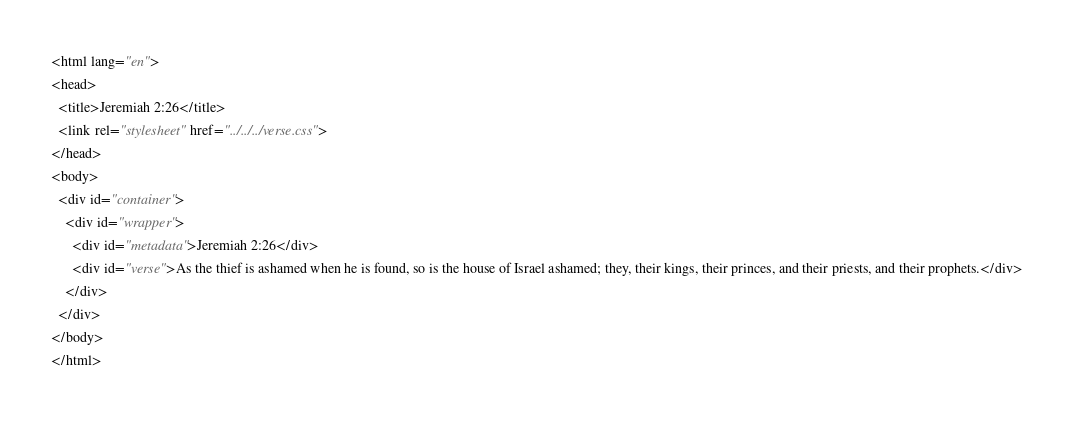Convert code to text. <code><loc_0><loc_0><loc_500><loc_500><_HTML_><html lang="en">
<head>
  <title>Jeremiah 2:26</title>
  <link rel="stylesheet" href="../../../verse.css">
</head>
<body>
  <div id="container">
    <div id="wrapper">
      <div id="metadata">Jeremiah 2:26</div>
      <div id="verse">As the thief is ashamed when he is found, so is the house of Israel ashamed; they, their kings, their princes, and their priests, and their prophets.</div>
    </div>
  </div>
</body>
</html></code> 